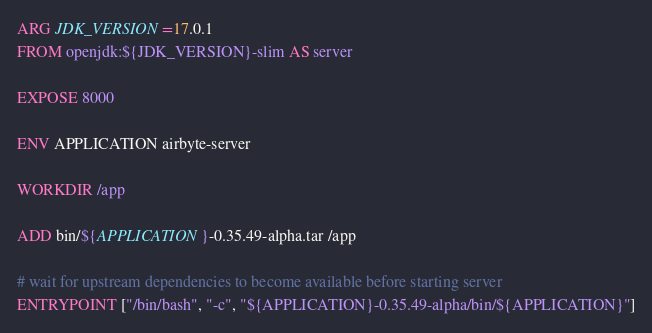Convert code to text. <code><loc_0><loc_0><loc_500><loc_500><_Dockerfile_>ARG JDK_VERSION=17.0.1
FROM openjdk:${JDK_VERSION}-slim AS server

EXPOSE 8000

ENV APPLICATION airbyte-server

WORKDIR /app

ADD bin/${APPLICATION}-0.35.49-alpha.tar /app

# wait for upstream dependencies to become available before starting server
ENTRYPOINT ["/bin/bash", "-c", "${APPLICATION}-0.35.49-alpha/bin/${APPLICATION}"]
</code> 